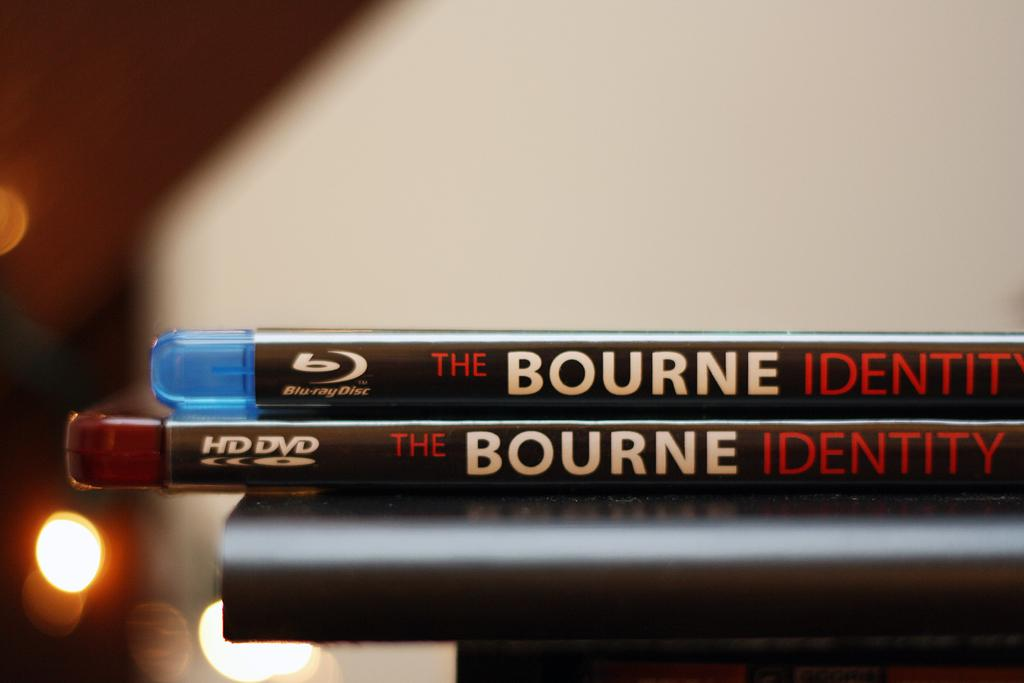<image>
Share a concise interpretation of the image provided. The bourne identify movie sits on top of the table 